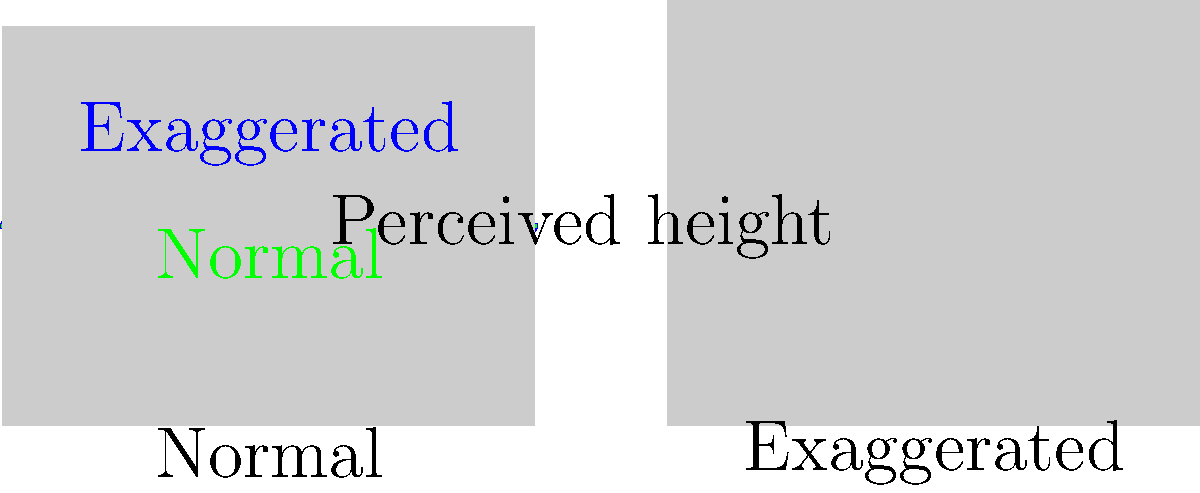In fashion photography, models often use a technique to enhance their perceived height and create a more elongated silhouette. This involves slightly exaggerating the natural curvature of the spine. Based on the diagram, explain how this exaggeration of spinal curvature affects the perceived body shape in photographs, and why it's an effective technique for creating a more statuesque appearance. 1. Natural spine curvature: The spine naturally has an S-shaped curve when viewed from the side. This is represented by the dashed green line in the diagram.

2. Exaggerated curvature: The blue line shows an exaggerated spinal curve, where the model slightly arches their back more than usual.

3. Effect on perceived height: 
   a. The exaggerated curve creates more space between the top and bottom of the spine.
   b. This increased vertical distance is represented by the arrow labeled "Perceived height."
   c. The greater this distance, the taller the model appears in the photograph.

4. Impact on silhouette:
   a. The left silhouette shows a normal posture.
   b. The right silhouette demonstrates the effect of the exaggerated curve.
   c. Notice how the right silhouette appears slightly taller and more elongated.

5. Overall effect:
   a. The exaggerated curve creates a more pronounced S-shape in the body.
   b. This S-shape is associated with a graceful, elegant posture.
   c. The elongated appearance makes the model look taller and leaner.

6. Why it's effective:
   a. It subtly enhances height without looking unnatural.
   b. It creates a more dynamic and visually interesting silhouette.
   c. The curved line is more aesthetically pleasing than a straight line.
   d. It emphasizes the model's posture and body control, showcasing their expertise.

In fashion and editorial photography, this technique helps create more impactful and visually appealing images without the need for digital manipulation.
Answer: Exaggerated spinal curvature increases perceived height and creates a more elongated, elegant silhouette by emphasizing the S-shape of the body. 